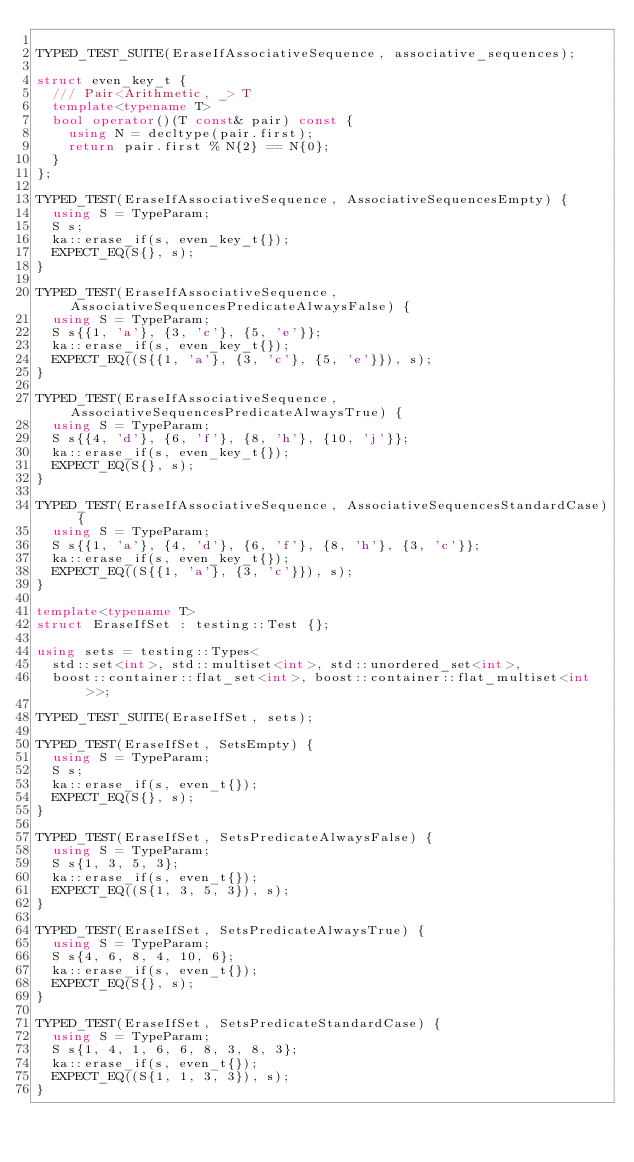<code> <loc_0><loc_0><loc_500><loc_500><_C++_>
TYPED_TEST_SUITE(EraseIfAssociativeSequence, associative_sequences);

struct even_key_t {
  /// Pair<Arithmetic, _> T
  template<typename T>
  bool operator()(T const& pair) const {
    using N = decltype(pair.first);
    return pair.first % N{2} == N{0};
  }
};

TYPED_TEST(EraseIfAssociativeSequence, AssociativeSequencesEmpty) {
  using S = TypeParam;
  S s;
  ka::erase_if(s, even_key_t{});
  EXPECT_EQ(S{}, s);
}

TYPED_TEST(EraseIfAssociativeSequence, AssociativeSequencesPredicateAlwaysFalse) {
  using S = TypeParam;
  S s{{1, 'a'}, {3, 'c'}, {5, 'e'}};
  ka::erase_if(s, even_key_t{});
  EXPECT_EQ((S{{1, 'a'}, {3, 'c'}, {5, 'e'}}), s);
}

TYPED_TEST(EraseIfAssociativeSequence, AssociativeSequencesPredicateAlwaysTrue) {
  using S = TypeParam;
  S s{{4, 'd'}, {6, 'f'}, {8, 'h'}, {10, 'j'}};
  ka::erase_if(s, even_key_t{});
  EXPECT_EQ(S{}, s);
}

TYPED_TEST(EraseIfAssociativeSequence, AssociativeSequencesStandardCase) {
  using S = TypeParam;
  S s{{1, 'a'}, {4, 'd'}, {6, 'f'}, {8, 'h'}, {3, 'c'}};
  ka::erase_if(s, even_key_t{});
  EXPECT_EQ((S{{1, 'a'}, {3, 'c'}}), s);
}

template<typename T>
struct EraseIfSet : testing::Test {};

using sets = testing::Types<
  std::set<int>, std::multiset<int>, std::unordered_set<int>,
  boost::container::flat_set<int>, boost::container::flat_multiset<int>>;

TYPED_TEST_SUITE(EraseIfSet, sets);

TYPED_TEST(EraseIfSet, SetsEmpty) {
  using S = TypeParam;
  S s;
  ka::erase_if(s, even_t{});
  EXPECT_EQ(S{}, s);
}

TYPED_TEST(EraseIfSet, SetsPredicateAlwaysFalse) {
  using S = TypeParam;
  S s{1, 3, 5, 3};
  ka::erase_if(s, even_t{});
  EXPECT_EQ((S{1, 3, 5, 3}), s);
}

TYPED_TEST(EraseIfSet, SetsPredicateAlwaysTrue) {
  using S = TypeParam;
  S s{4, 6, 8, 4, 10, 6};
  ka::erase_if(s, even_t{});
  EXPECT_EQ(S{}, s);
}

TYPED_TEST(EraseIfSet, SetsPredicateStandardCase) {
  using S = TypeParam;
  S s{1, 4, 1, 6, 6, 8, 3, 8, 3};
  ka::erase_if(s, even_t{});
  EXPECT_EQ((S{1, 1, 3, 3}), s);
}
</code> 